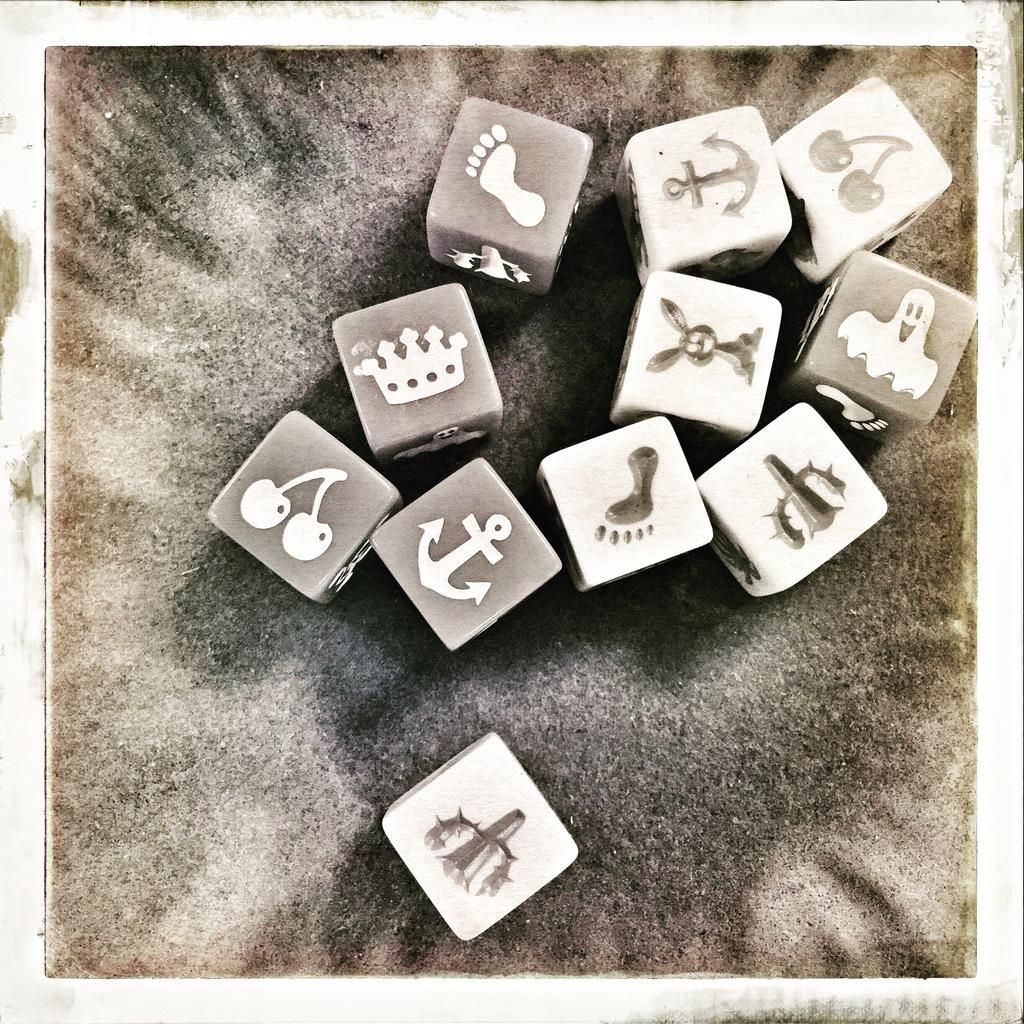What is the main subject of the image? The main subject of the image is a photo. What can be seen in the photo? The photo contains some symbols. What type of journey is depicted in the image? There is no journey depicted in the image, as it only contains a photo with symbols. What scene is taking place in the image? There is no scene taking place in the image, as it only contains a photo with symbols. 